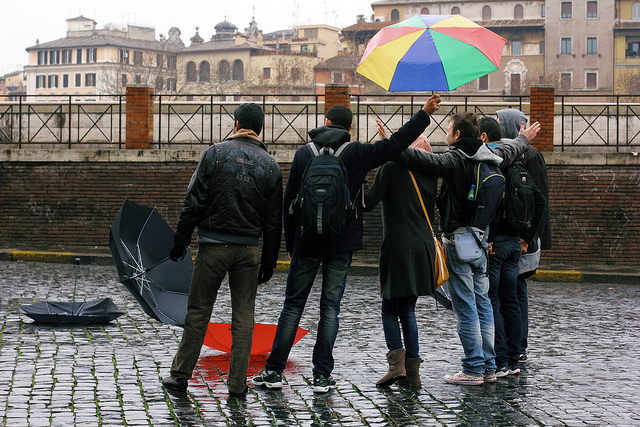Are there any notable colors in the image that stand out? Indeed, the multicolored umbrella stands out vibrantly against the otherwise muted tones of the cityscape and the dreary weather, adding a cheerful splash of color to the overcast day. 